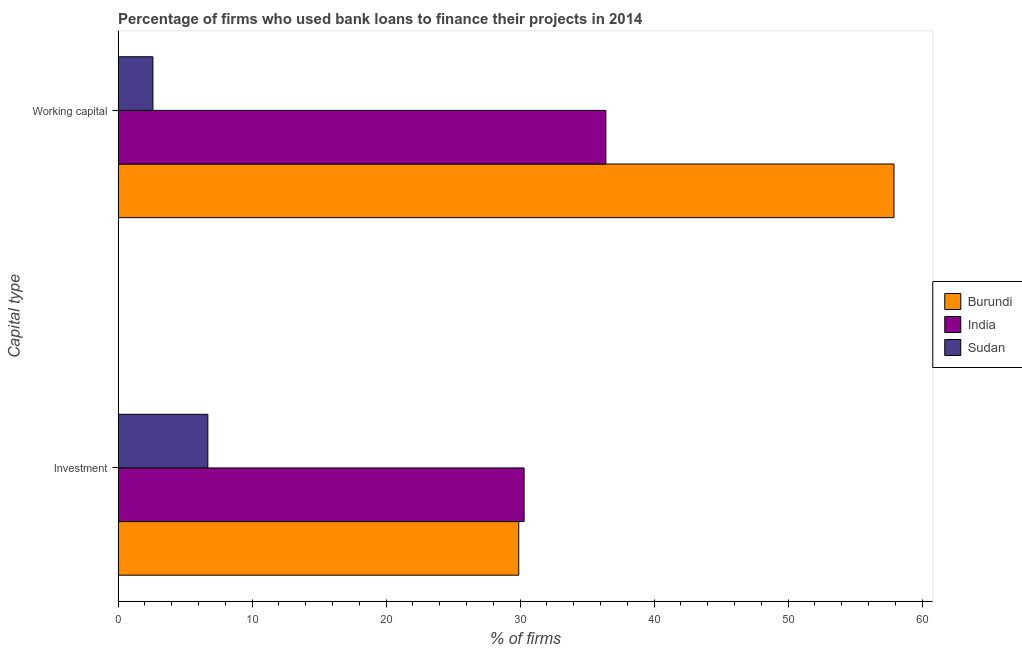How many different coloured bars are there?
Keep it short and to the point. 3. How many groups of bars are there?
Offer a very short reply. 2. Are the number of bars per tick equal to the number of legend labels?
Provide a succinct answer. Yes. How many bars are there on the 1st tick from the bottom?
Your answer should be very brief. 3. What is the label of the 2nd group of bars from the top?
Give a very brief answer. Investment. What is the percentage of firms using banks to finance investment in India?
Your answer should be very brief. 30.3. Across all countries, what is the maximum percentage of firms using banks to finance working capital?
Provide a succinct answer. 57.9. Across all countries, what is the minimum percentage of firms using banks to finance investment?
Offer a very short reply. 6.7. In which country was the percentage of firms using banks to finance investment minimum?
Offer a terse response. Sudan. What is the total percentage of firms using banks to finance working capital in the graph?
Offer a very short reply. 96.9. What is the difference between the percentage of firms using banks to finance investment in Burundi and that in Sudan?
Your answer should be compact. 23.2. What is the difference between the percentage of firms using banks to finance investment in Sudan and the percentage of firms using banks to finance working capital in India?
Offer a very short reply. -29.7. What is the average percentage of firms using banks to finance working capital per country?
Give a very brief answer. 32.3. What is the ratio of the percentage of firms using banks to finance working capital in Burundi to that in India?
Provide a succinct answer. 1.59. Is the percentage of firms using banks to finance investment in Sudan less than that in India?
Your answer should be very brief. Yes. In how many countries, is the percentage of firms using banks to finance investment greater than the average percentage of firms using banks to finance investment taken over all countries?
Give a very brief answer. 2. What does the 3rd bar from the top in Working capital represents?
Your answer should be compact. Burundi. What does the 1st bar from the bottom in Working capital represents?
Offer a very short reply. Burundi. How many countries are there in the graph?
Make the answer very short. 3. What is the difference between two consecutive major ticks on the X-axis?
Offer a terse response. 10. Are the values on the major ticks of X-axis written in scientific E-notation?
Provide a succinct answer. No. Does the graph contain any zero values?
Your response must be concise. No. Does the graph contain grids?
Your answer should be compact. No. How many legend labels are there?
Ensure brevity in your answer.  3. How are the legend labels stacked?
Provide a succinct answer. Vertical. What is the title of the graph?
Give a very brief answer. Percentage of firms who used bank loans to finance their projects in 2014. What is the label or title of the X-axis?
Offer a terse response. % of firms. What is the label or title of the Y-axis?
Offer a very short reply. Capital type. What is the % of firms of Burundi in Investment?
Make the answer very short. 29.9. What is the % of firms of India in Investment?
Provide a succinct answer. 30.3. What is the % of firms in Burundi in Working capital?
Your answer should be very brief. 57.9. What is the % of firms of India in Working capital?
Ensure brevity in your answer.  36.4. What is the % of firms of Sudan in Working capital?
Your response must be concise. 2.6. Across all Capital type, what is the maximum % of firms in Burundi?
Make the answer very short. 57.9. Across all Capital type, what is the maximum % of firms of India?
Your answer should be very brief. 36.4. Across all Capital type, what is the maximum % of firms in Sudan?
Offer a terse response. 6.7. Across all Capital type, what is the minimum % of firms in Burundi?
Your answer should be compact. 29.9. Across all Capital type, what is the minimum % of firms of India?
Provide a short and direct response. 30.3. Across all Capital type, what is the minimum % of firms in Sudan?
Your answer should be compact. 2.6. What is the total % of firms in Burundi in the graph?
Keep it short and to the point. 87.8. What is the total % of firms of India in the graph?
Your answer should be compact. 66.7. What is the difference between the % of firms of Burundi in Investment and that in Working capital?
Provide a succinct answer. -28. What is the difference between the % of firms of India in Investment and that in Working capital?
Offer a very short reply. -6.1. What is the difference between the % of firms in Sudan in Investment and that in Working capital?
Give a very brief answer. 4.1. What is the difference between the % of firms in Burundi in Investment and the % of firms in Sudan in Working capital?
Your answer should be compact. 27.3. What is the difference between the % of firms in India in Investment and the % of firms in Sudan in Working capital?
Your answer should be compact. 27.7. What is the average % of firms in Burundi per Capital type?
Provide a succinct answer. 43.9. What is the average % of firms in India per Capital type?
Your answer should be compact. 33.35. What is the average % of firms of Sudan per Capital type?
Make the answer very short. 4.65. What is the difference between the % of firms in Burundi and % of firms in Sudan in Investment?
Your answer should be compact. 23.2. What is the difference between the % of firms in India and % of firms in Sudan in Investment?
Provide a short and direct response. 23.6. What is the difference between the % of firms of Burundi and % of firms of Sudan in Working capital?
Your answer should be compact. 55.3. What is the difference between the % of firms in India and % of firms in Sudan in Working capital?
Your response must be concise. 33.8. What is the ratio of the % of firms of Burundi in Investment to that in Working capital?
Offer a terse response. 0.52. What is the ratio of the % of firms of India in Investment to that in Working capital?
Give a very brief answer. 0.83. What is the ratio of the % of firms of Sudan in Investment to that in Working capital?
Offer a terse response. 2.58. What is the difference between the highest and the second highest % of firms of India?
Keep it short and to the point. 6.1. What is the difference between the highest and the lowest % of firms in India?
Your answer should be very brief. 6.1. What is the difference between the highest and the lowest % of firms in Sudan?
Your answer should be compact. 4.1. 